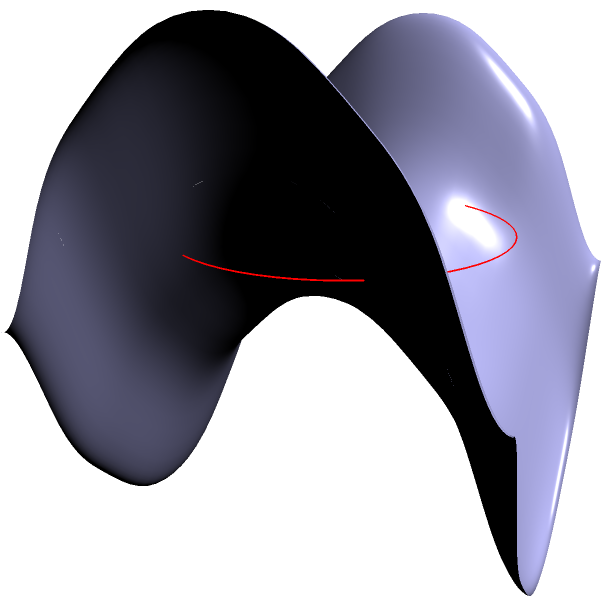On a saddle-shaped surface described by the equation $z = 0.5(x^2 - y^2)$, a circle with radius 1.5 units is drawn on the plane $z = 0.5$. Calculate the area of this circle on the saddle surface. How does it compare to the area of a circle with the same radius on a flat plane? To solve this problem, we need to follow these steps:

1) First, recall that the area of a circle on a flat plane is given by $A = \pi r^2$, where $r$ is the radius.

2) On a flat plane, the area of a circle with radius 1.5 units would be:
   $A_{flat} = \pi (1.5)^2 = 2.25\pi \approx 7.0686$ square units

3) On a curved surface, the area is generally different. We need to use the concept of Gaussian curvature ($K$) to determine how the area changes.

4) For a saddle surface described by $z = 0.5(x^2 - y^2)$, the Gaussian curvature is constant and negative: $K = -1$

5) The area of a circle on a surface with constant negative curvature is given by:
   $A_{curved} = 4\pi \sinh^2(\frac{r}{2}\sqrt{-K}) / (-K)$
   where $\sinh$ is the hyperbolic sine function

6) Substituting our values ($r = 1.5$, $K = -1$):
   $A_{curved} = 4\pi \sinh^2(\frac{1.5}{2}\sqrt{1}) / 1$
               $= 4\pi \sinh^2(0.75)$
               $\approx 7.2533$ square units

7) Comparing the two areas:
   $A_{curved} - A_{flat} \approx 7.2533 - 7.0686 = 0.1847$ square units

The area on the saddle surface is slightly larger than on a flat plane.
Answer: $7.2533$ square units; $0.1847$ square units larger than on a flat plane 